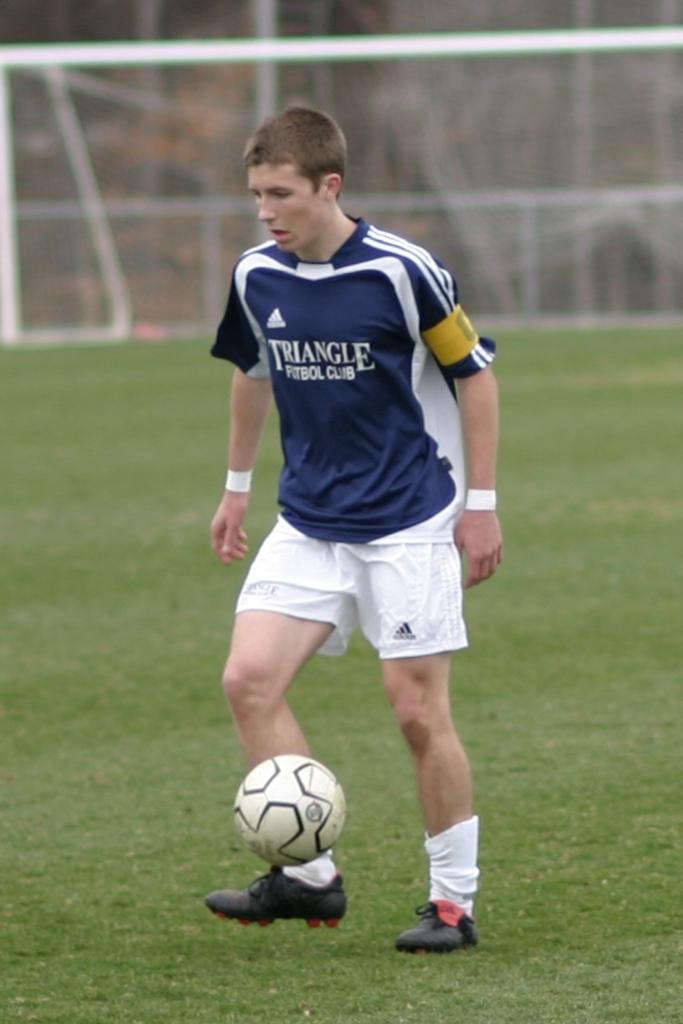What shape is written on the jersey?
Ensure brevity in your answer.  Triangle. What kind of club is advertised on his jersey?
Give a very brief answer. Triangle. 